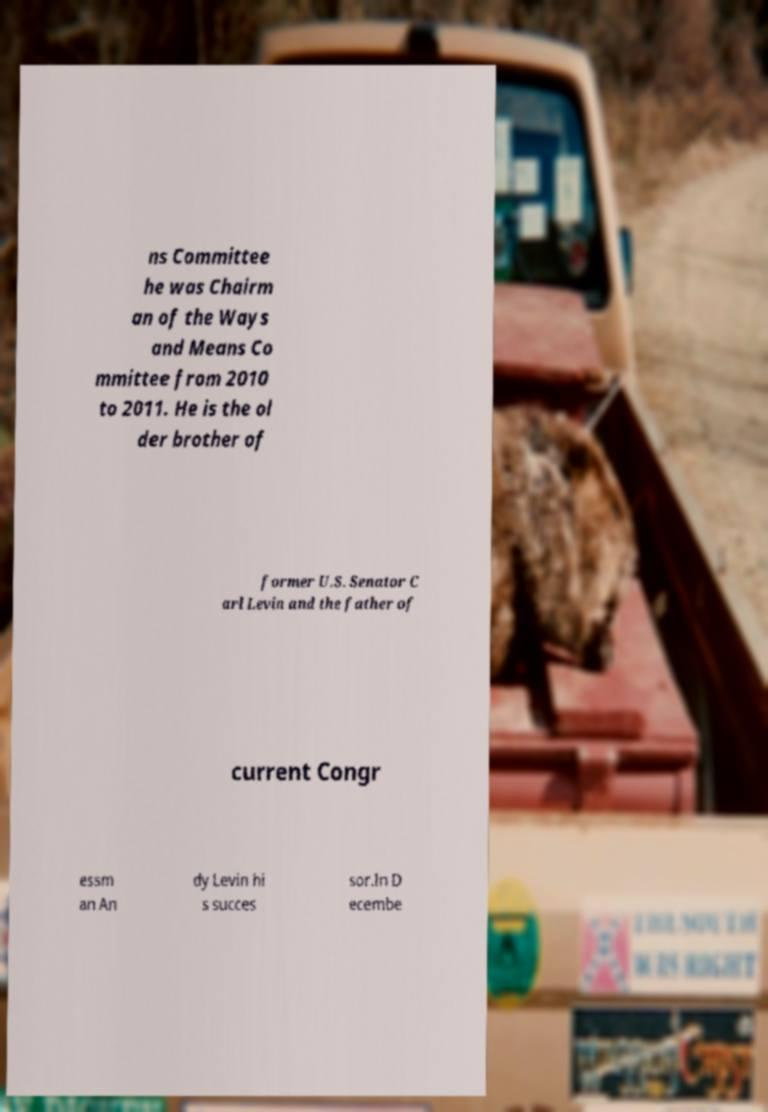Please read and relay the text visible in this image. What does it say? ns Committee he was Chairm an of the Ways and Means Co mmittee from 2010 to 2011. He is the ol der brother of former U.S. Senator C arl Levin and the father of current Congr essm an An dy Levin hi s succes sor.In D ecembe 